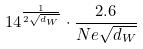Convert formula to latex. <formula><loc_0><loc_0><loc_500><loc_500>1 4 ^ { \frac { 1 } { 2 \sqrt { d _ { W } } } } \cdot \frac { 2 . 6 } { N e \sqrt { d _ { W } } }</formula> 